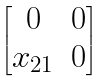Convert formula to latex. <formula><loc_0><loc_0><loc_500><loc_500>\begin{bmatrix} 0 & 0 \\ x _ { 2 1 } & 0 \end{bmatrix}</formula> 